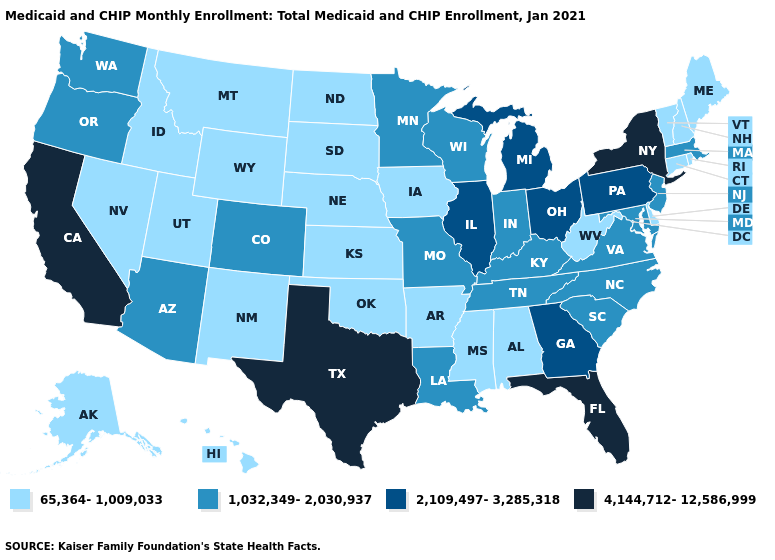Does Oklahoma have the lowest value in the USA?
Be succinct. Yes. What is the value of South Dakota?
Give a very brief answer. 65,364-1,009,033. What is the value of Wisconsin?
Concise answer only. 1,032,349-2,030,937. What is the lowest value in the Northeast?
Keep it brief. 65,364-1,009,033. Does Montana have the same value as Oregon?
Quick response, please. No. What is the value of Missouri?
Short answer required. 1,032,349-2,030,937. Name the states that have a value in the range 2,109,497-3,285,318?
Quick response, please. Georgia, Illinois, Michigan, Ohio, Pennsylvania. Name the states that have a value in the range 4,144,712-12,586,999?
Answer briefly. California, Florida, New York, Texas. Name the states that have a value in the range 4,144,712-12,586,999?
Give a very brief answer. California, Florida, New York, Texas. Does North Carolina have a lower value than New York?
Keep it brief. Yes. What is the lowest value in states that border Oregon?
Be succinct. 65,364-1,009,033. What is the lowest value in the USA?
Short answer required. 65,364-1,009,033. What is the value of New York?
Answer briefly. 4,144,712-12,586,999. Which states have the highest value in the USA?
Short answer required. California, Florida, New York, Texas. Does New York have the highest value in the Northeast?
Write a very short answer. Yes. 